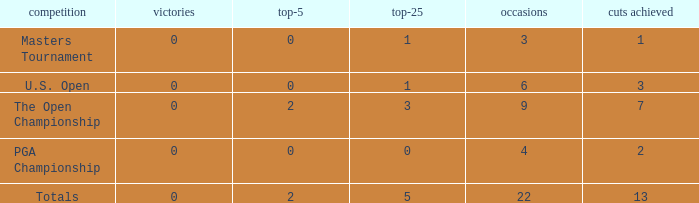What is the average number of cuts made for events with under 4 entries and more than 0 wins? None. 